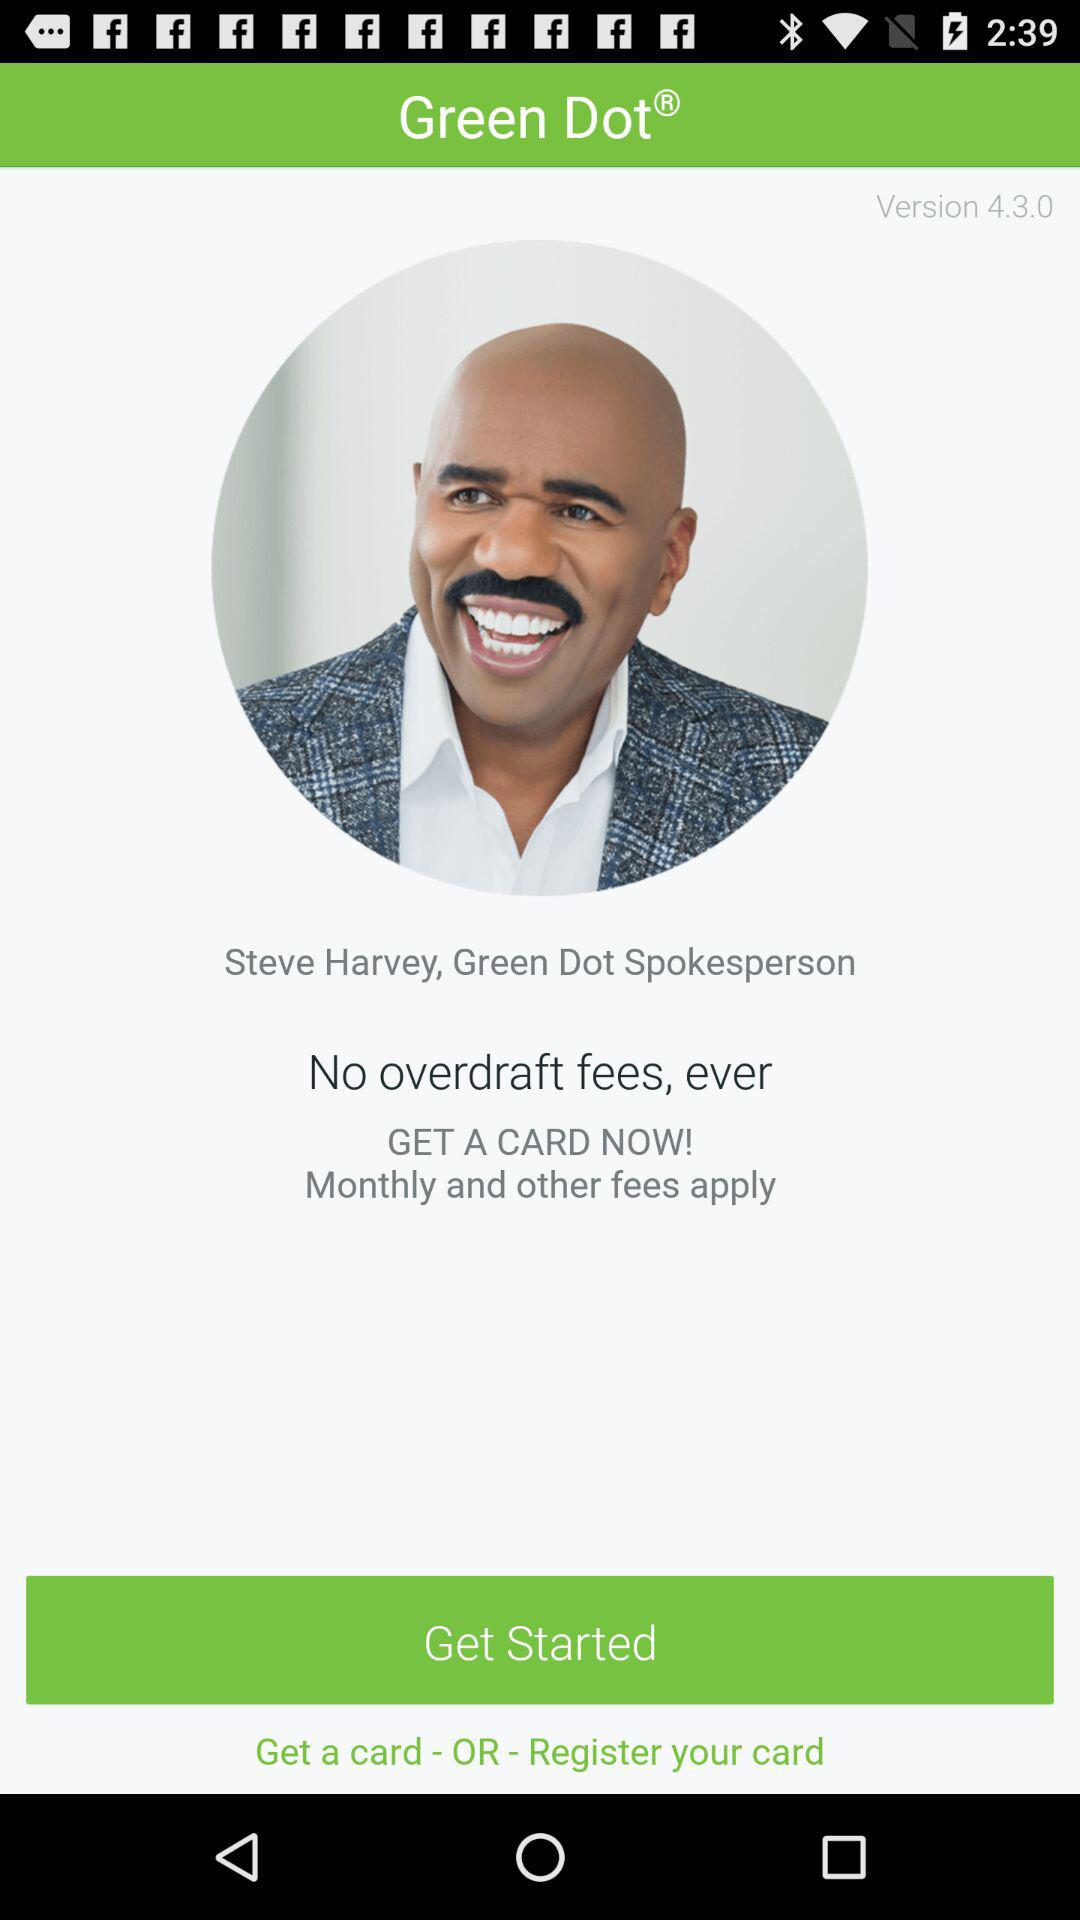What is the application name? The application name is "Green Dot". 